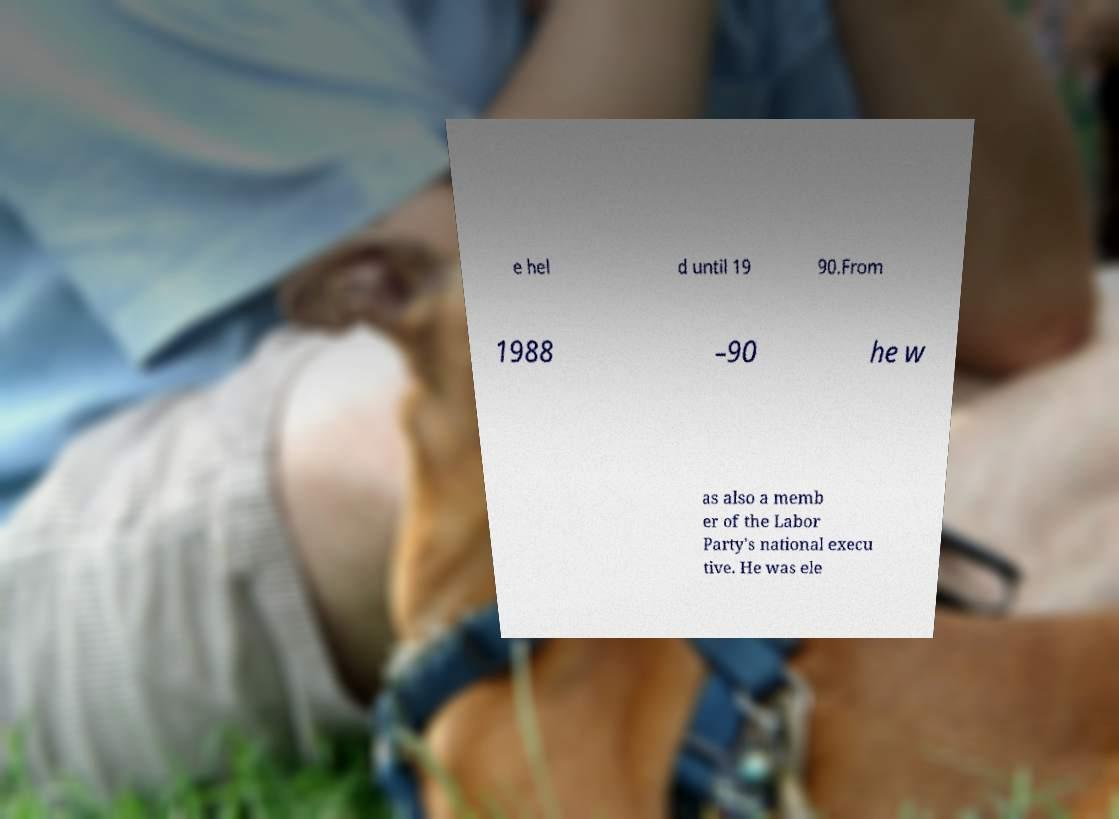There's text embedded in this image that I need extracted. Can you transcribe it verbatim? e hel d until 19 90.From 1988 –90 he w as also a memb er of the Labor Party's national execu tive. He was ele 